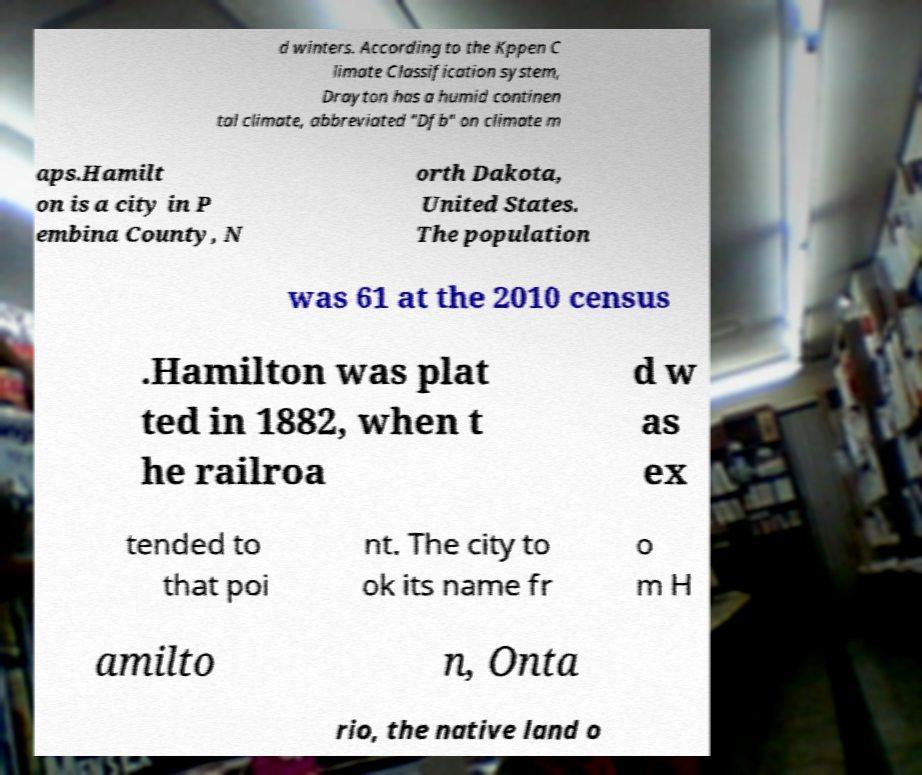Could you extract and type out the text from this image? d winters. According to the Kppen C limate Classification system, Drayton has a humid continen tal climate, abbreviated "Dfb" on climate m aps.Hamilt on is a city in P embina County, N orth Dakota, United States. The population was 61 at the 2010 census .Hamilton was plat ted in 1882, when t he railroa d w as ex tended to that poi nt. The city to ok its name fr o m H amilto n, Onta rio, the native land o 